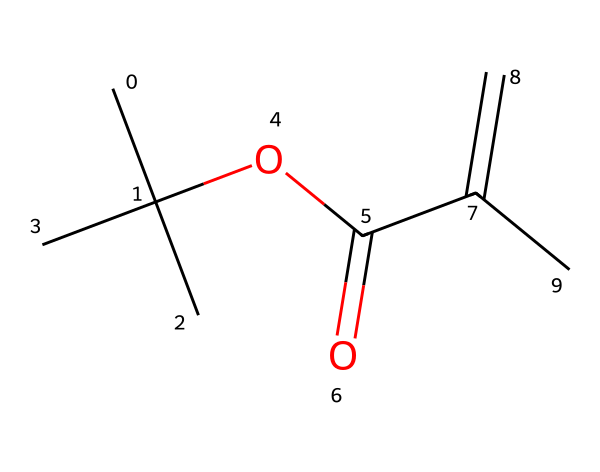What is the main functional group in this monomer? The monomer contains an ester functional group, indicated by the -OC(=O) structure, which is part of the carbon chain.
Answer: ester How many carbon atoms are in this monomer? By analyzing the SMILES structure, there are seven carbon atoms represented, including the ones in the alkyl and alkene segments.
Answer: seven What is the degree of unsaturation in this chemical? The degree of unsaturation can be determined by counting the number of rings and multiple bonds; there is one alkene double bond, indicating a degree of unsaturation of one.
Answer: one Which part of the structure indicates this chemical can polymerize? The presence of the double bond (C=C) suggests that this monomer can undergo addition polymerization, which is typical for alkenes.
Answer: double bond Is this monomer likely to be polar or nonpolar? Considering the ester functional group present and the overall structure, the chemical is likely to be polar due to the electronegative oxygen atoms.
Answer: polar 